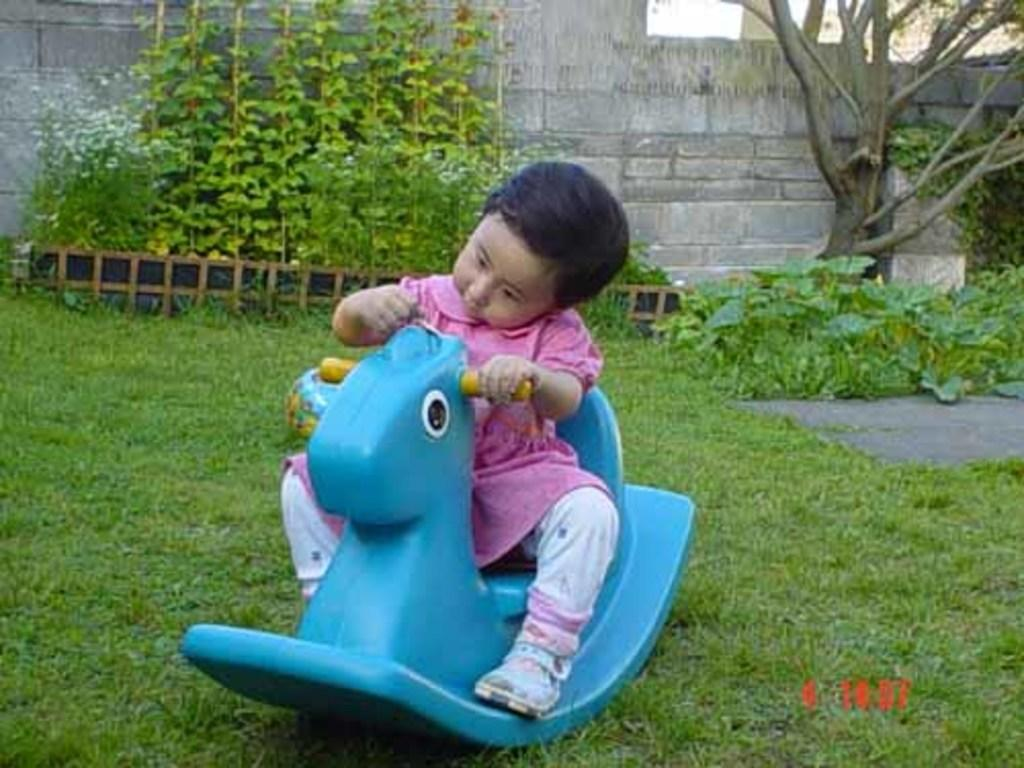What is the main subject of the image? The main subject of the image is a kid. What is the kid doing in the image? The kid is sitting on a toy in the image. What type of environment is visible in the image? There is grass, plants, and trees in the image, suggesting a natural setting. What can be seen in the background of the image? There is a wall in the background of the image. What type of basketball skills can be observed in the image? There is no basketball present in the image, so no such skills can be observed. What religious symbols are visible in the image? There are no religious symbols present in the image. 